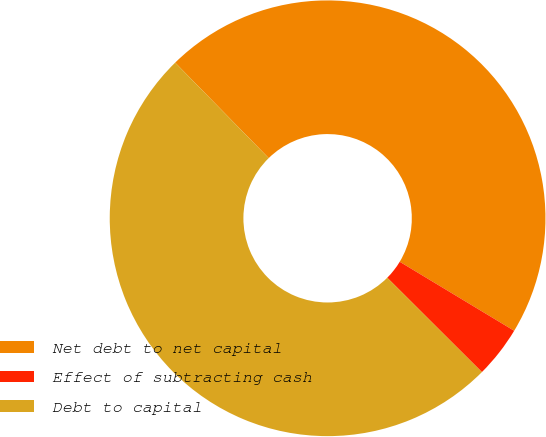Convert chart to OTSL. <chart><loc_0><loc_0><loc_500><loc_500><pie_chart><fcel>Net debt to net capital<fcel>Effect of subtracting cash<fcel>Debt to capital<nl><fcel>45.97%<fcel>3.84%<fcel>50.19%<nl></chart> 